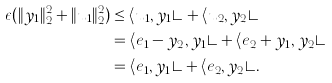Convert formula to latex. <formula><loc_0><loc_0><loc_500><loc_500>\epsilon ( \| y _ { 1 } \| _ { 2 } ^ { 2 } + \| u _ { 1 } \| _ { 2 } ^ { 2 } ) & \leq \langle u _ { 1 } , y _ { 1 } \rangle + \langle u _ { 2 } , y _ { 2 } \rangle \\ & = \langle e _ { 1 } - y _ { 2 } , y _ { 1 } \rangle + \langle e _ { 2 } + y _ { 1 } , y _ { 2 } \rangle \\ & = \langle e _ { 1 } , y _ { 1 } \rangle + \langle e _ { 2 } , y _ { 2 } \rangle .</formula> 